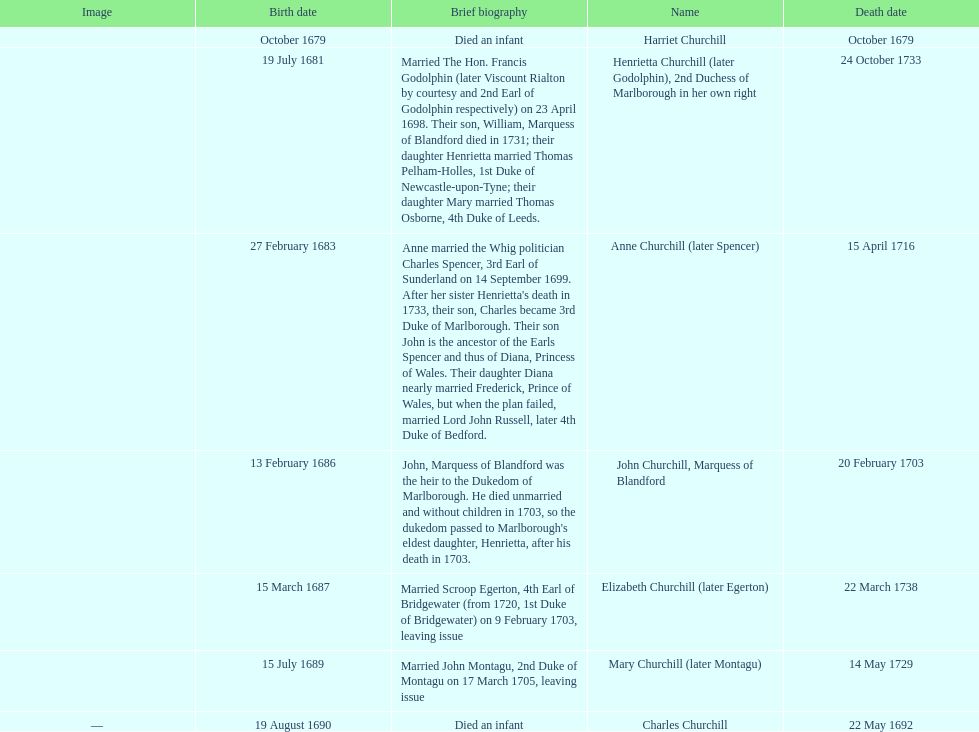How long did anne churchill/spencer live? 33. 